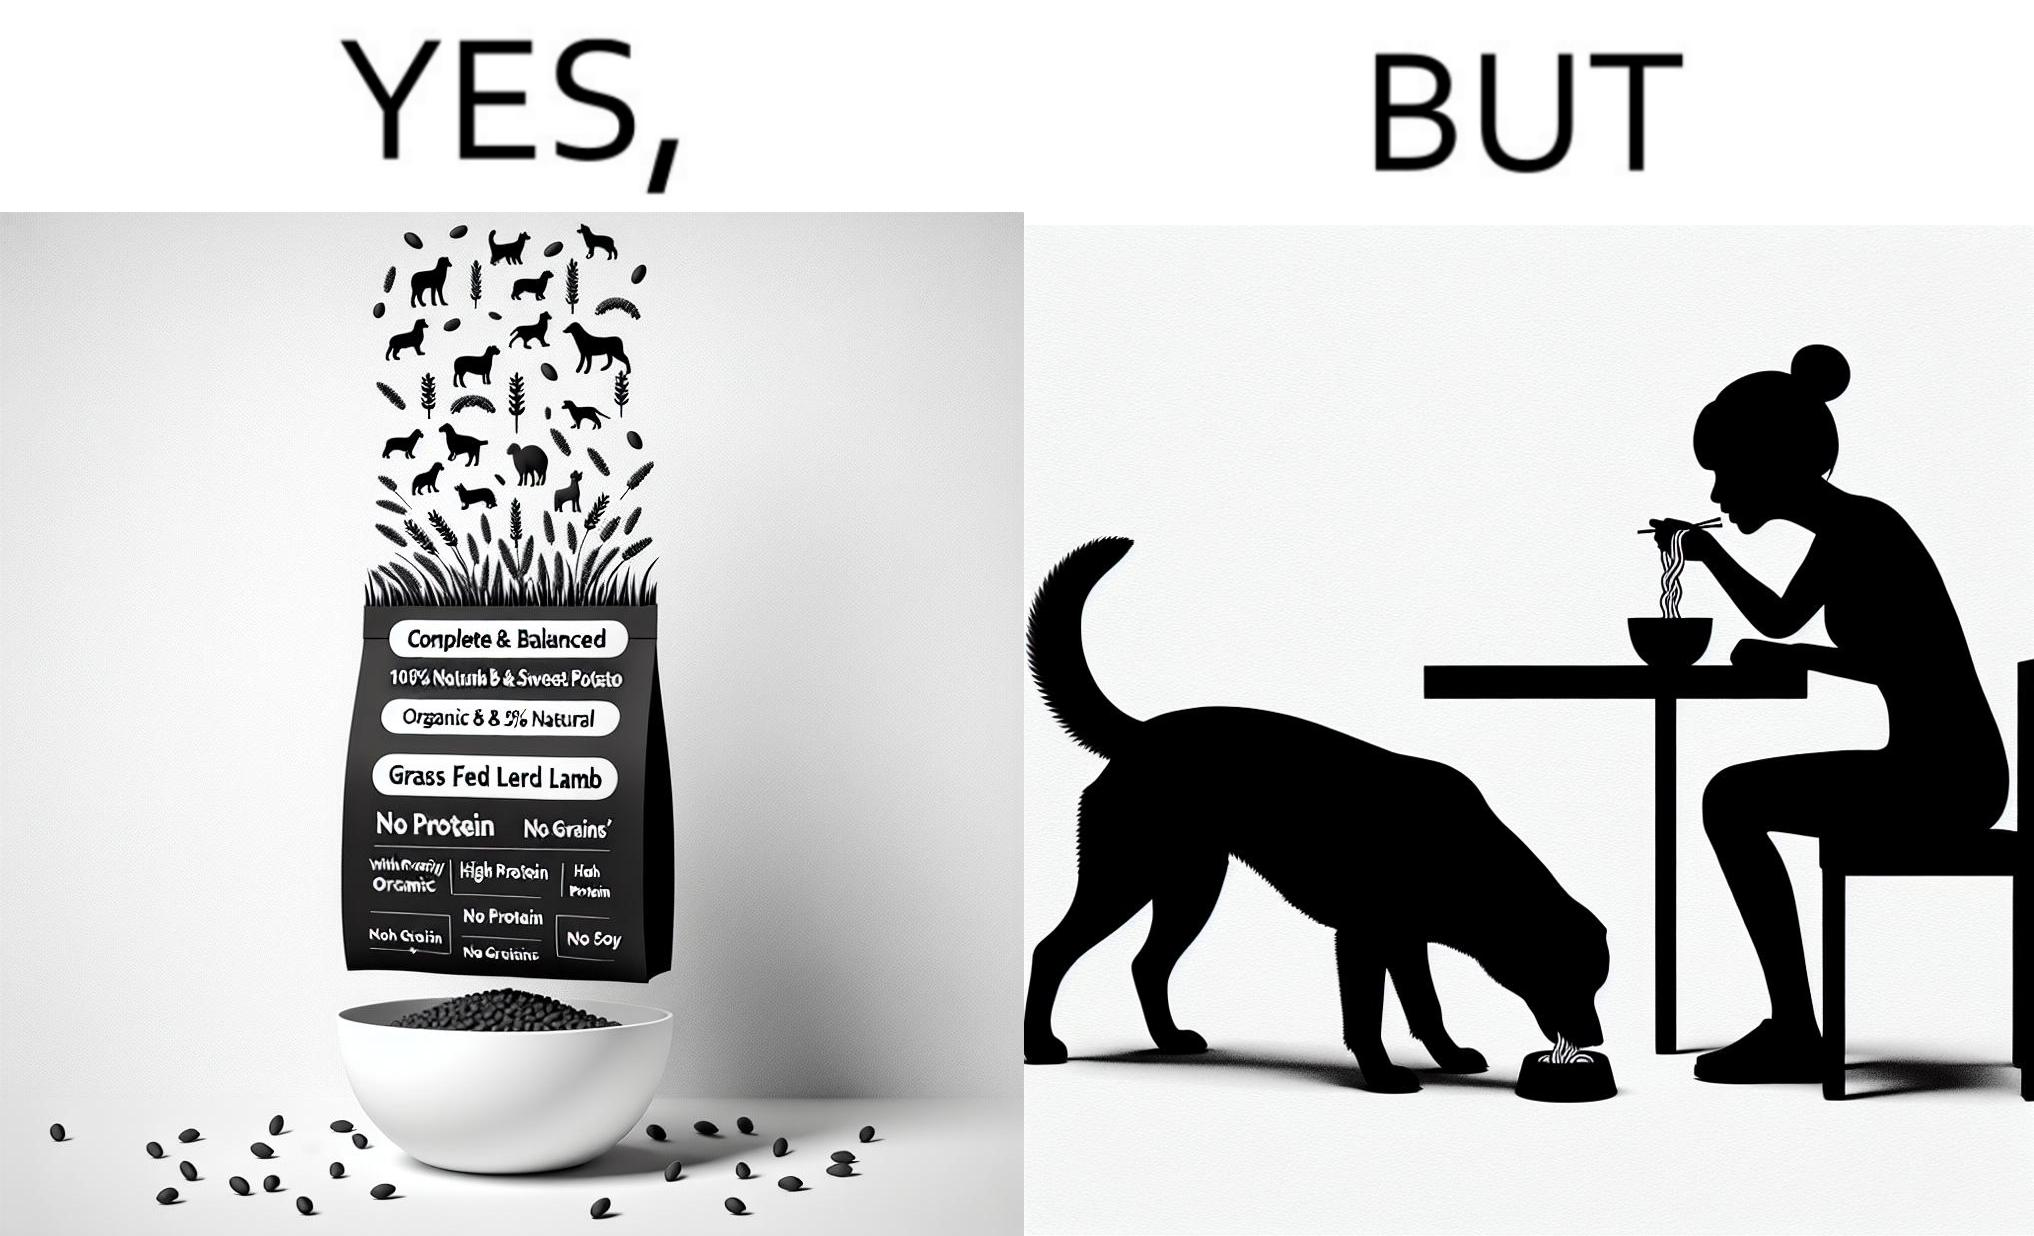Why is this image considered satirical? The image is funny because while the food for the dog that the woman pours is well balanced, the food that she herself is eating is bad for her health. 